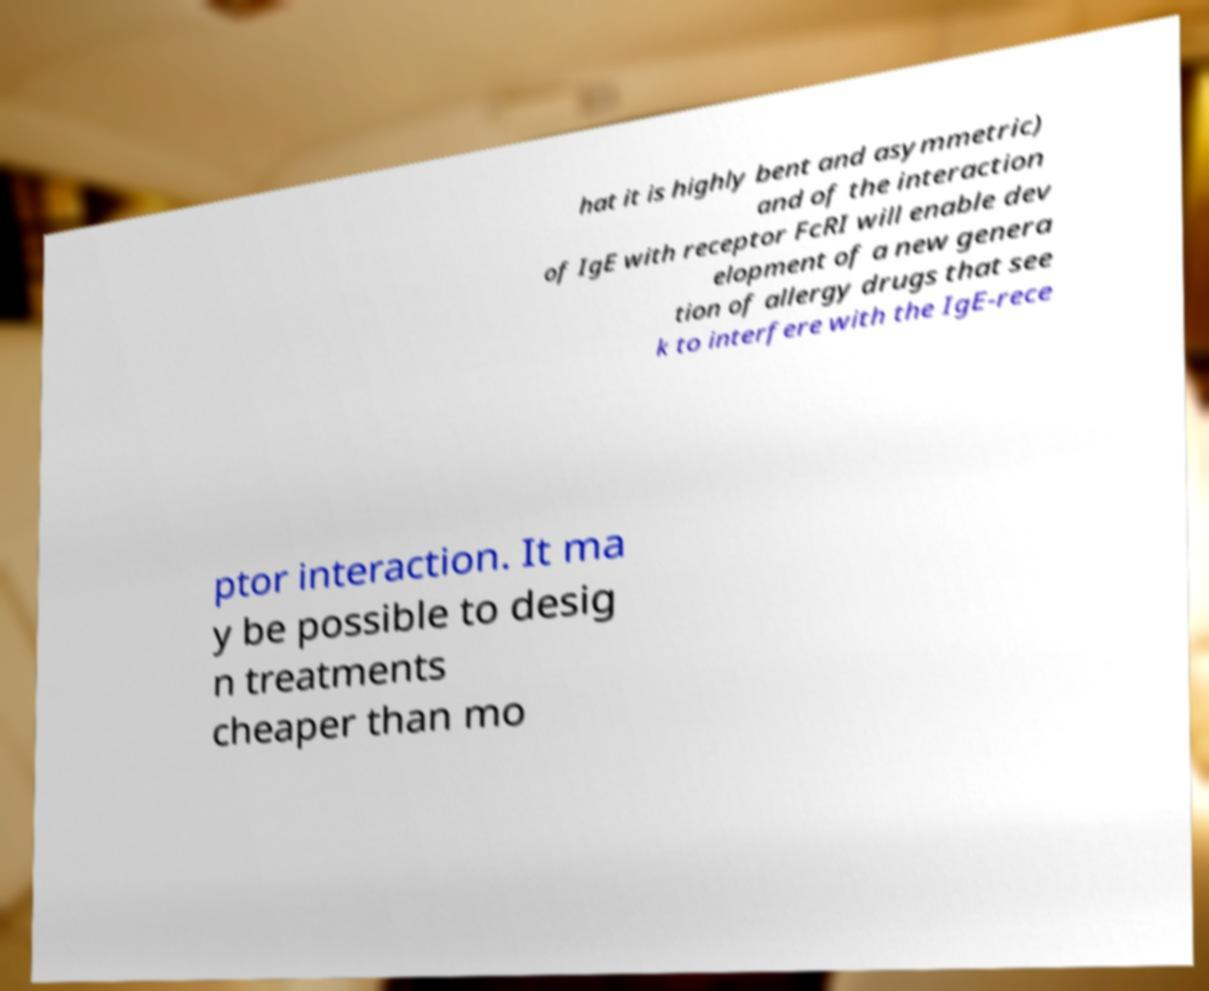Could you assist in decoding the text presented in this image and type it out clearly? hat it is highly bent and asymmetric) and of the interaction of IgE with receptor FcRI will enable dev elopment of a new genera tion of allergy drugs that see k to interfere with the IgE-rece ptor interaction. It ma y be possible to desig n treatments cheaper than mo 